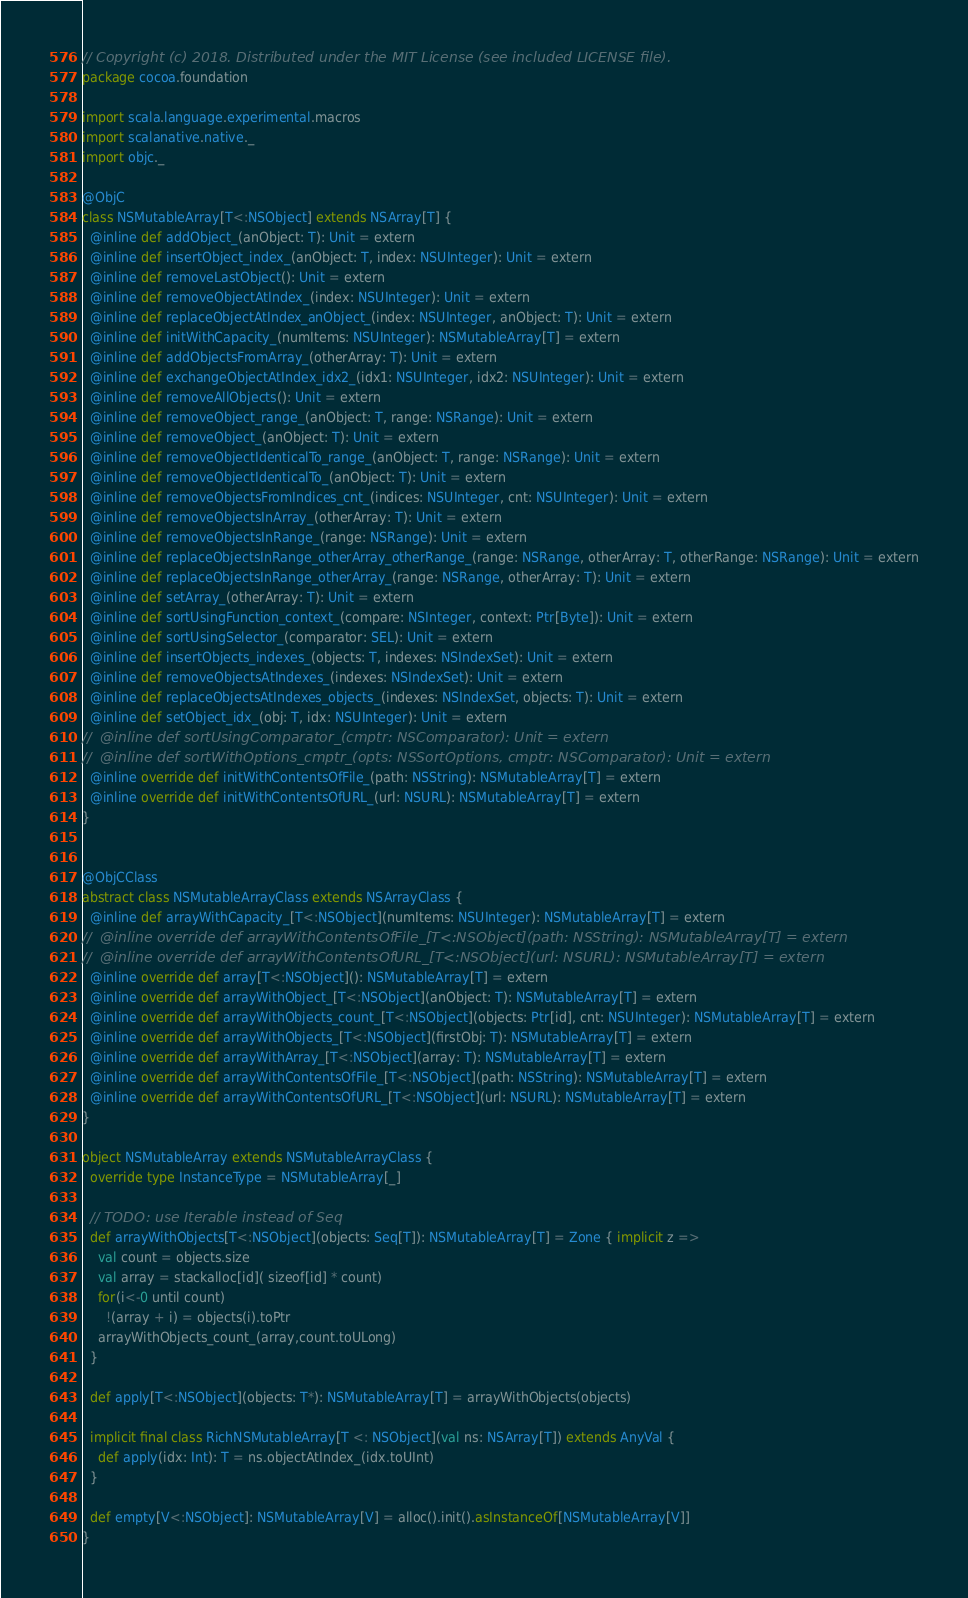Convert code to text. <code><loc_0><loc_0><loc_500><loc_500><_Scala_>// Copyright (c) 2018. Distributed under the MIT License (see included LICENSE file).
package cocoa.foundation

import scala.language.experimental.macros
import scalanative.native._
import objc._

@ObjC
class NSMutableArray[T<:NSObject] extends NSArray[T] {
  @inline def addObject_(anObject: T): Unit = extern
  @inline def insertObject_index_(anObject: T, index: NSUInteger): Unit = extern
  @inline def removeLastObject(): Unit = extern
  @inline def removeObjectAtIndex_(index: NSUInteger): Unit = extern
  @inline def replaceObjectAtIndex_anObject_(index: NSUInteger, anObject: T): Unit = extern
  @inline def initWithCapacity_(numItems: NSUInteger): NSMutableArray[T] = extern
  @inline def addObjectsFromArray_(otherArray: T): Unit = extern
  @inline def exchangeObjectAtIndex_idx2_(idx1: NSUInteger, idx2: NSUInteger): Unit = extern
  @inline def removeAllObjects(): Unit = extern
  @inline def removeObject_range_(anObject: T, range: NSRange): Unit = extern
  @inline def removeObject_(anObject: T): Unit = extern
  @inline def removeObjectIdenticalTo_range_(anObject: T, range: NSRange): Unit = extern
  @inline def removeObjectIdenticalTo_(anObject: T): Unit = extern
  @inline def removeObjectsFromIndices_cnt_(indices: NSUInteger, cnt: NSUInteger): Unit = extern
  @inline def removeObjectsInArray_(otherArray: T): Unit = extern
  @inline def removeObjectsInRange_(range: NSRange): Unit = extern
  @inline def replaceObjectsInRange_otherArray_otherRange_(range: NSRange, otherArray: T, otherRange: NSRange): Unit = extern
  @inline def replaceObjectsInRange_otherArray_(range: NSRange, otherArray: T): Unit = extern
  @inline def setArray_(otherArray: T): Unit = extern
  @inline def sortUsingFunction_context_(compare: NSInteger, context: Ptr[Byte]): Unit = extern
  @inline def sortUsingSelector_(comparator: SEL): Unit = extern
  @inline def insertObjects_indexes_(objects: T, indexes: NSIndexSet): Unit = extern
  @inline def removeObjectsAtIndexes_(indexes: NSIndexSet): Unit = extern
  @inline def replaceObjectsAtIndexes_objects_(indexes: NSIndexSet, objects: T): Unit = extern
  @inline def setObject_idx_(obj: T, idx: NSUInteger): Unit = extern
//  @inline def sortUsingComparator_(cmptr: NSComparator): Unit = extern
//  @inline def sortWithOptions_cmptr_(opts: NSSortOptions, cmptr: NSComparator): Unit = extern
  @inline override def initWithContentsOfFile_(path: NSString): NSMutableArray[T] = extern
  @inline override def initWithContentsOfURL_(url: NSURL): NSMutableArray[T] = extern
}


@ObjCClass
abstract class NSMutableArrayClass extends NSArrayClass {
  @inline def arrayWithCapacity_[T<:NSObject](numItems: NSUInteger): NSMutableArray[T] = extern
//  @inline override def arrayWithContentsOfFile_[T<:NSObject](path: NSString): NSMutableArray[T] = extern
//  @inline override def arrayWithContentsOfURL_[T<:NSObject](url: NSURL): NSMutableArray[T] = extern
  @inline override def array[T<:NSObject](): NSMutableArray[T] = extern
  @inline override def arrayWithObject_[T<:NSObject](anObject: T): NSMutableArray[T] = extern
  @inline override def arrayWithObjects_count_[T<:NSObject](objects: Ptr[id], cnt: NSUInteger): NSMutableArray[T] = extern
  @inline override def arrayWithObjects_[T<:NSObject](firstObj: T): NSMutableArray[T] = extern
  @inline override def arrayWithArray_[T<:NSObject](array: T): NSMutableArray[T] = extern
  @inline override def arrayWithContentsOfFile_[T<:NSObject](path: NSString): NSMutableArray[T] = extern
  @inline override def arrayWithContentsOfURL_[T<:NSObject](url: NSURL): NSMutableArray[T] = extern
}

object NSMutableArray extends NSMutableArrayClass {
  override type InstanceType = NSMutableArray[_]

  // TODO: use Iterable instead of Seq
  def arrayWithObjects[T<:NSObject](objects: Seq[T]): NSMutableArray[T] = Zone { implicit z =>
    val count = objects.size
    val array = stackalloc[id]( sizeof[id] * count)
    for(i<-0 until count)
      !(array + i) = objects(i).toPtr
    arrayWithObjects_count_(array,count.toULong)
  }

  def apply[T<:NSObject](objects: T*): NSMutableArray[T] = arrayWithObjects(objects)

  implicit final class RichNSMutableArray[T <: NSObject](val ns: NSArray[T]) extends AnyVal {
    def apply(idx: Int): T = ns.objectAtIndex_(idx.toUInt)
  }

  def empty[V<:NSObject]: NSMutableArray[V] = alloc().init().asInstanceOf[NSMutableArray[V]]
}</code> 